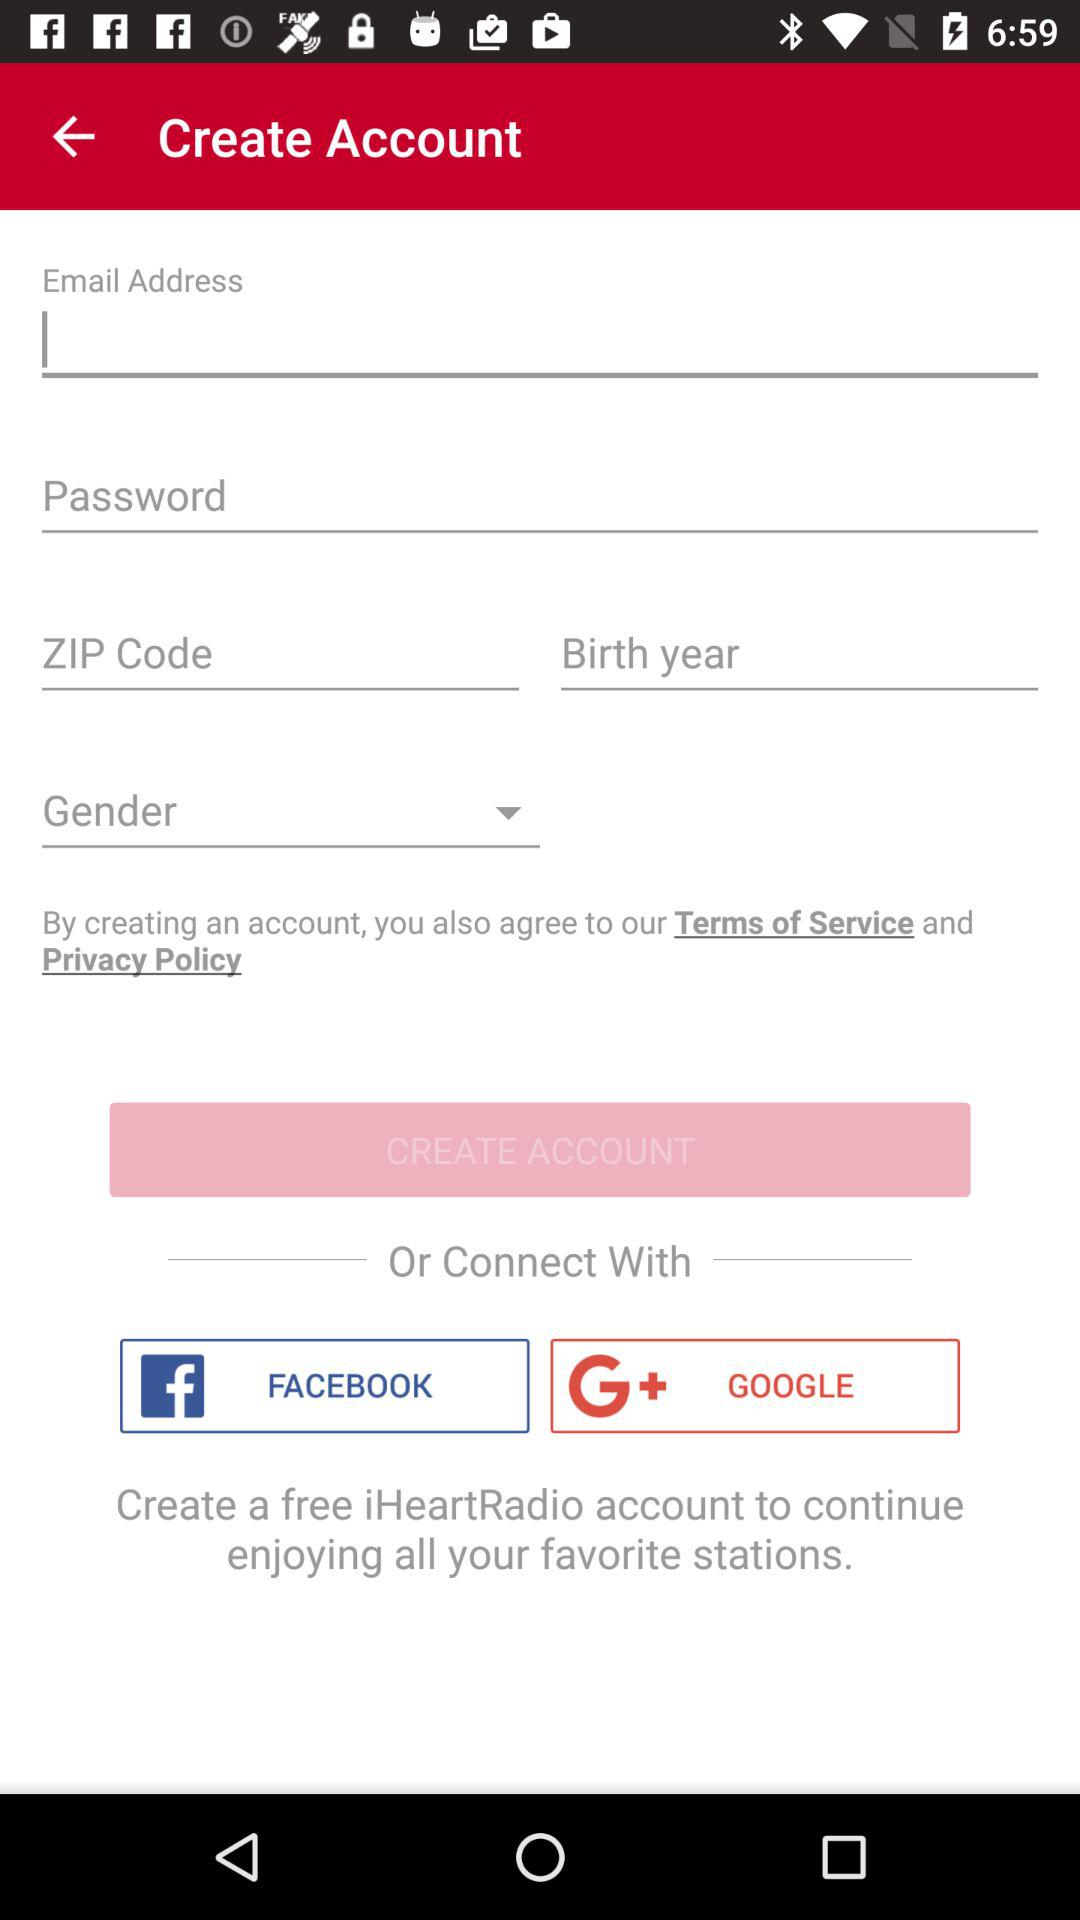What are the different options through which we can connect? The options are "FACEBOOK" and "GOOGLE". 